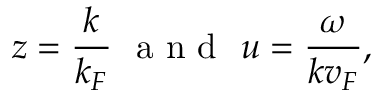Convert formula to latex. <formula><loc_0><loc_0><loc_500><loc_500>z = \frac { k } { k _ { F } } \ a n d \ u = \frac { \omega } { k v _ { F } } ,</formula> 